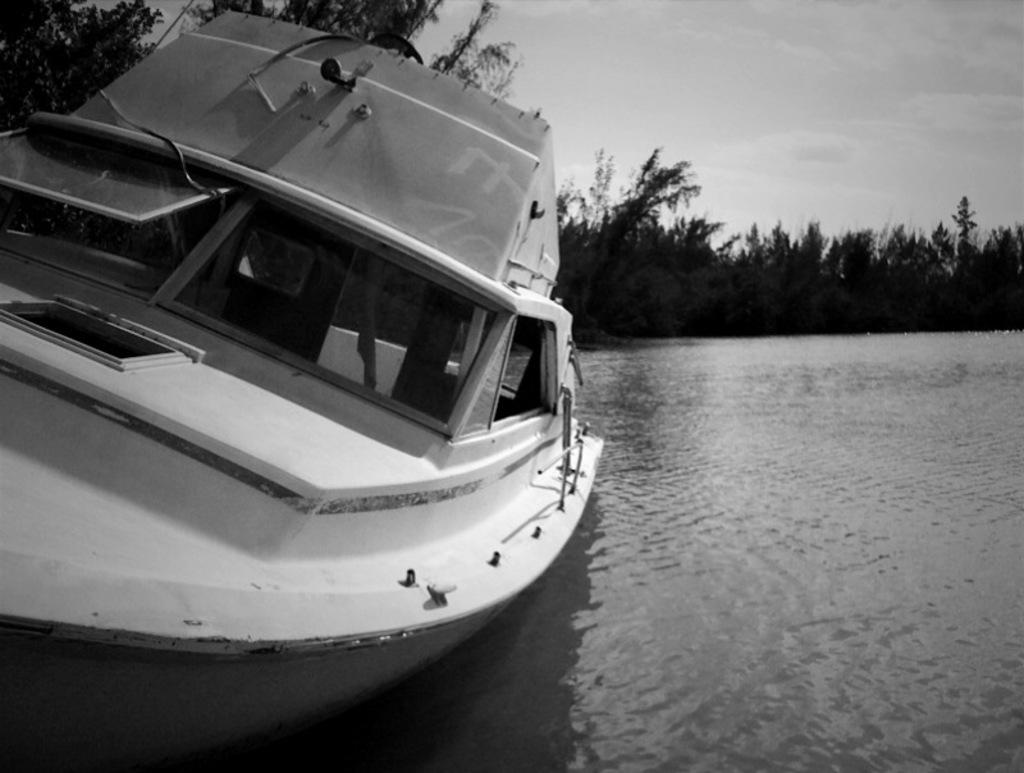What is the main subject of the image? There is a boat on the water in the image. What is the color scheme of the image? The image is in black and white color. What can be seen in the background of the image? There are trees and clouds in the sky in the background of the image. Can you see a hand waving good-bye from the boat in the image? There is no hand waving good-bye visible in the image. Is there a porter helping passengers on the boat in the image? There is no porter present in the image. 